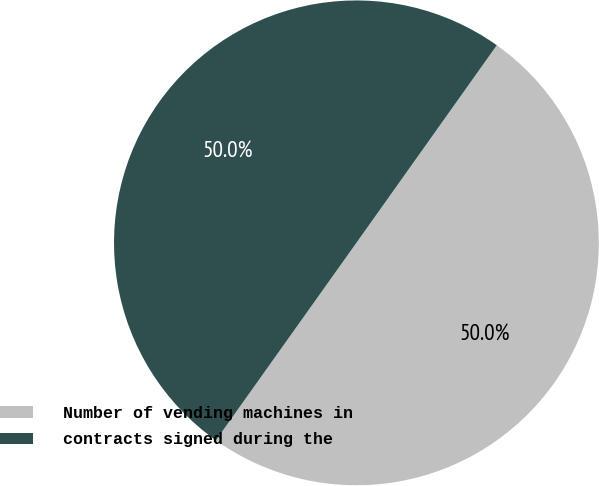Convert chart to OTSL. <chart><loc_0><loc_0><loc_500><loc_500><pie_chart><fcel>Number of vending machines in<fcel>contracts signed during the<nl><fcel>50.01%<fcel>49.99%<nl></chart> 